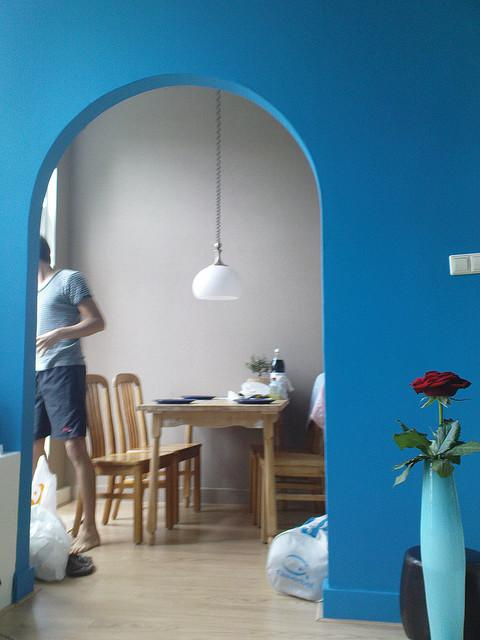What is furthest to the right?

Choices:
A) flower
B) elephant
C) cat
D) dog flower 